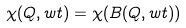<formula> <loc_0><loc_0><loc_500><loc_500>\chi ( Q , w t ) = \chi ( B ( Q , w t ) )</formula> 